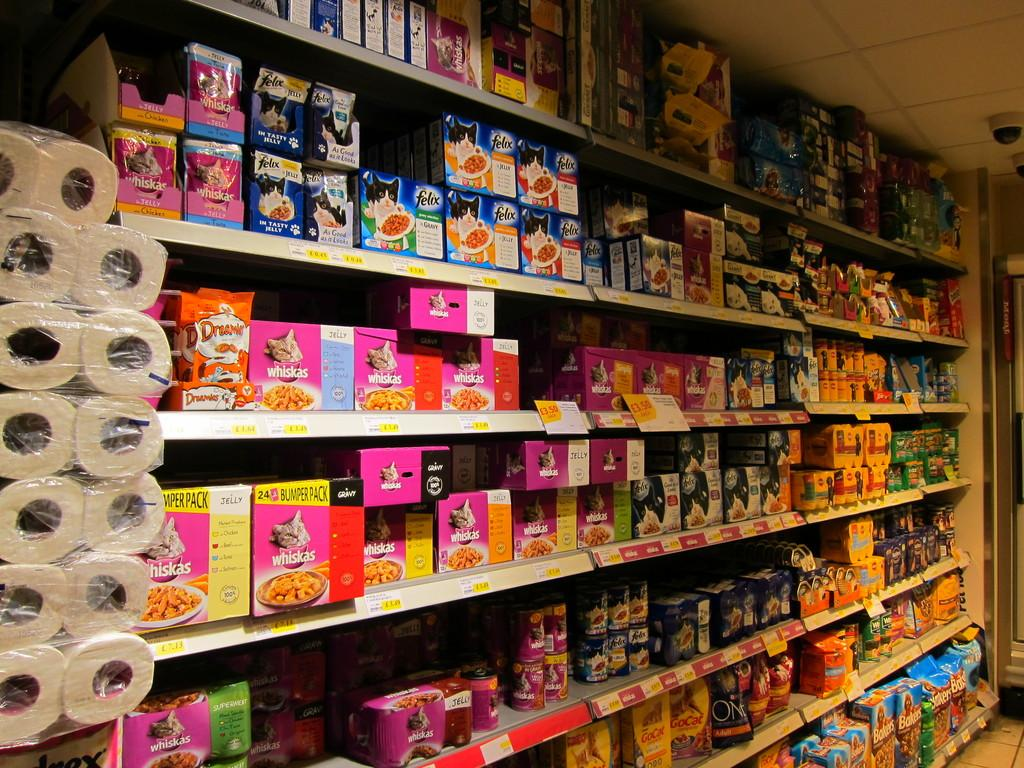<image>
Give a short and clear explanation of the subsequent image. A store isle has paper towels and Whiskies cat food. 